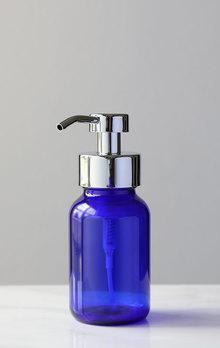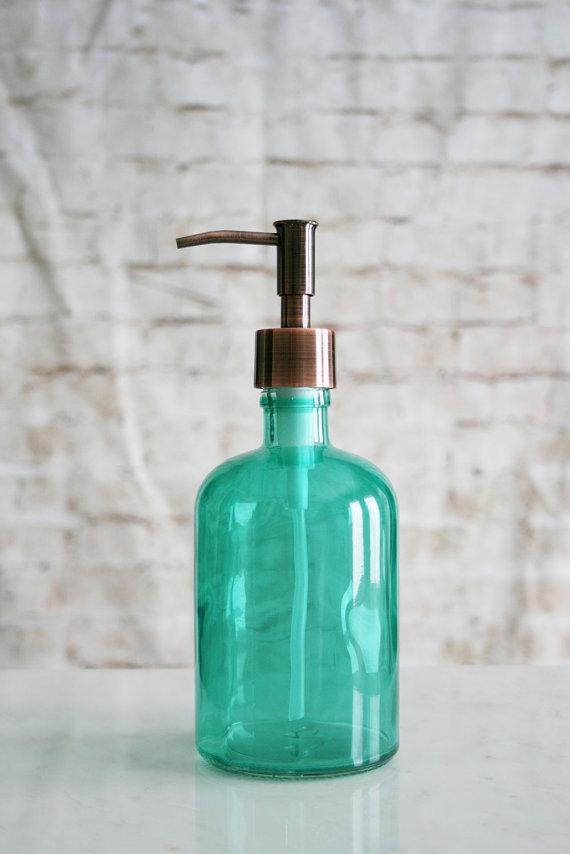The first image is the image on the left, the second image is the image on the right. Considering the images on both sides, is "In one image a canning jar has been accessorized with a metal pump top." valid? Answer yes or no. No. The first image is the image on the left, the second image is the image on the right. Given the left and right images, does the statement "There are two bottles total from both images." hold true? Answer yes or no. Yes. 